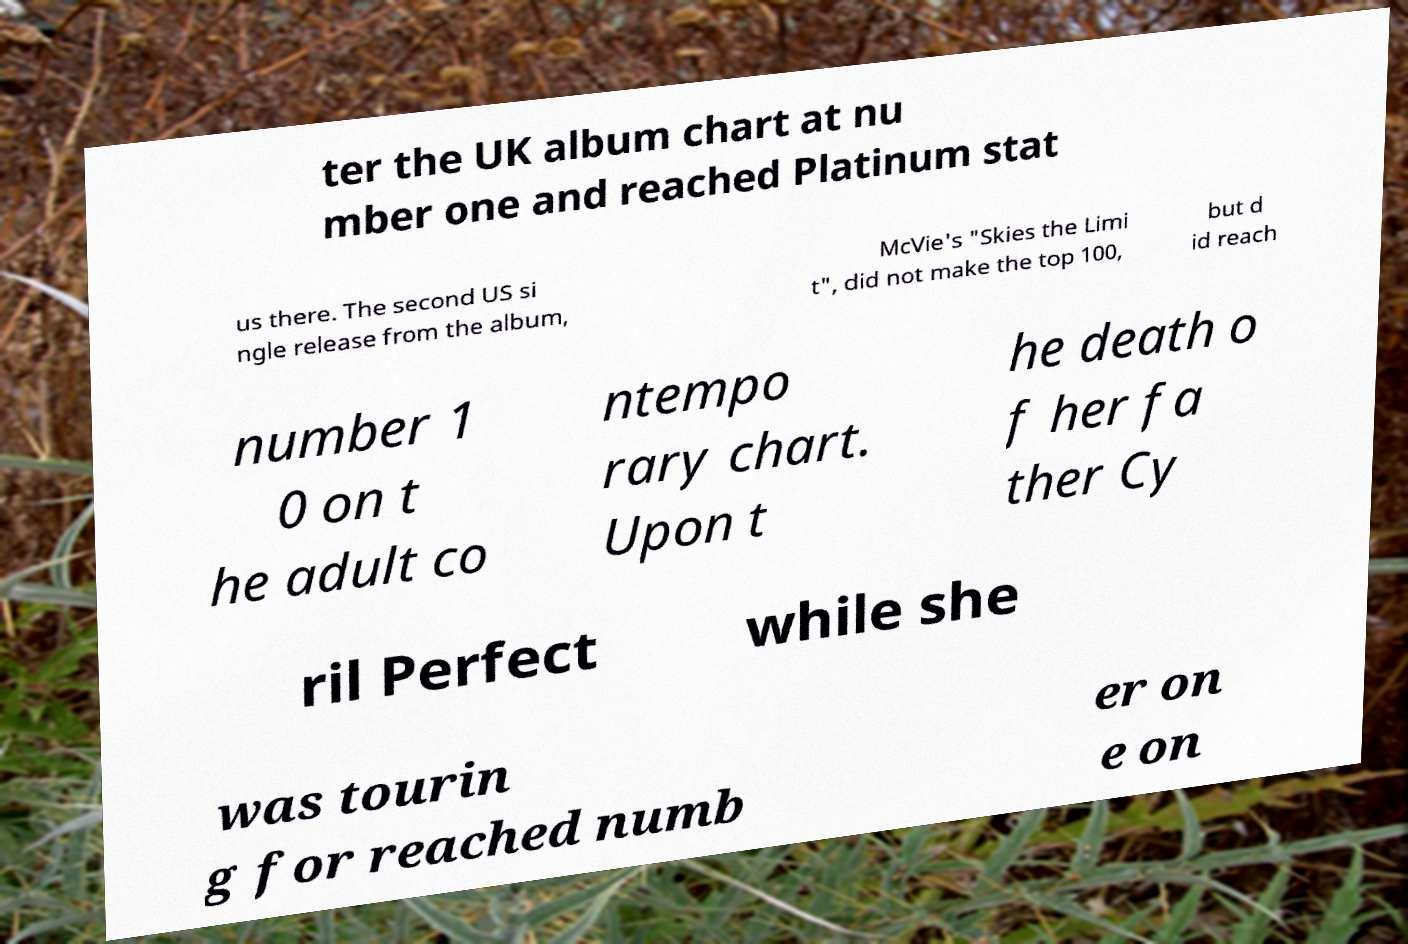Can you read and provide the text displayed in the image?This photo seems to have some interesting text. Can you extract and type it out for me? ter the UK album chart at nu mber one and reached Platinum stat us there. The second US si ngle release from the album, McVie's "Skies the Limi t", did not make the top 100, but d id reach number 1 0 on t he adult co ntempo rary chart. Upon t he death o f her fa ther Cy ril Perfect while she was tourin g for reached numb er on e on 